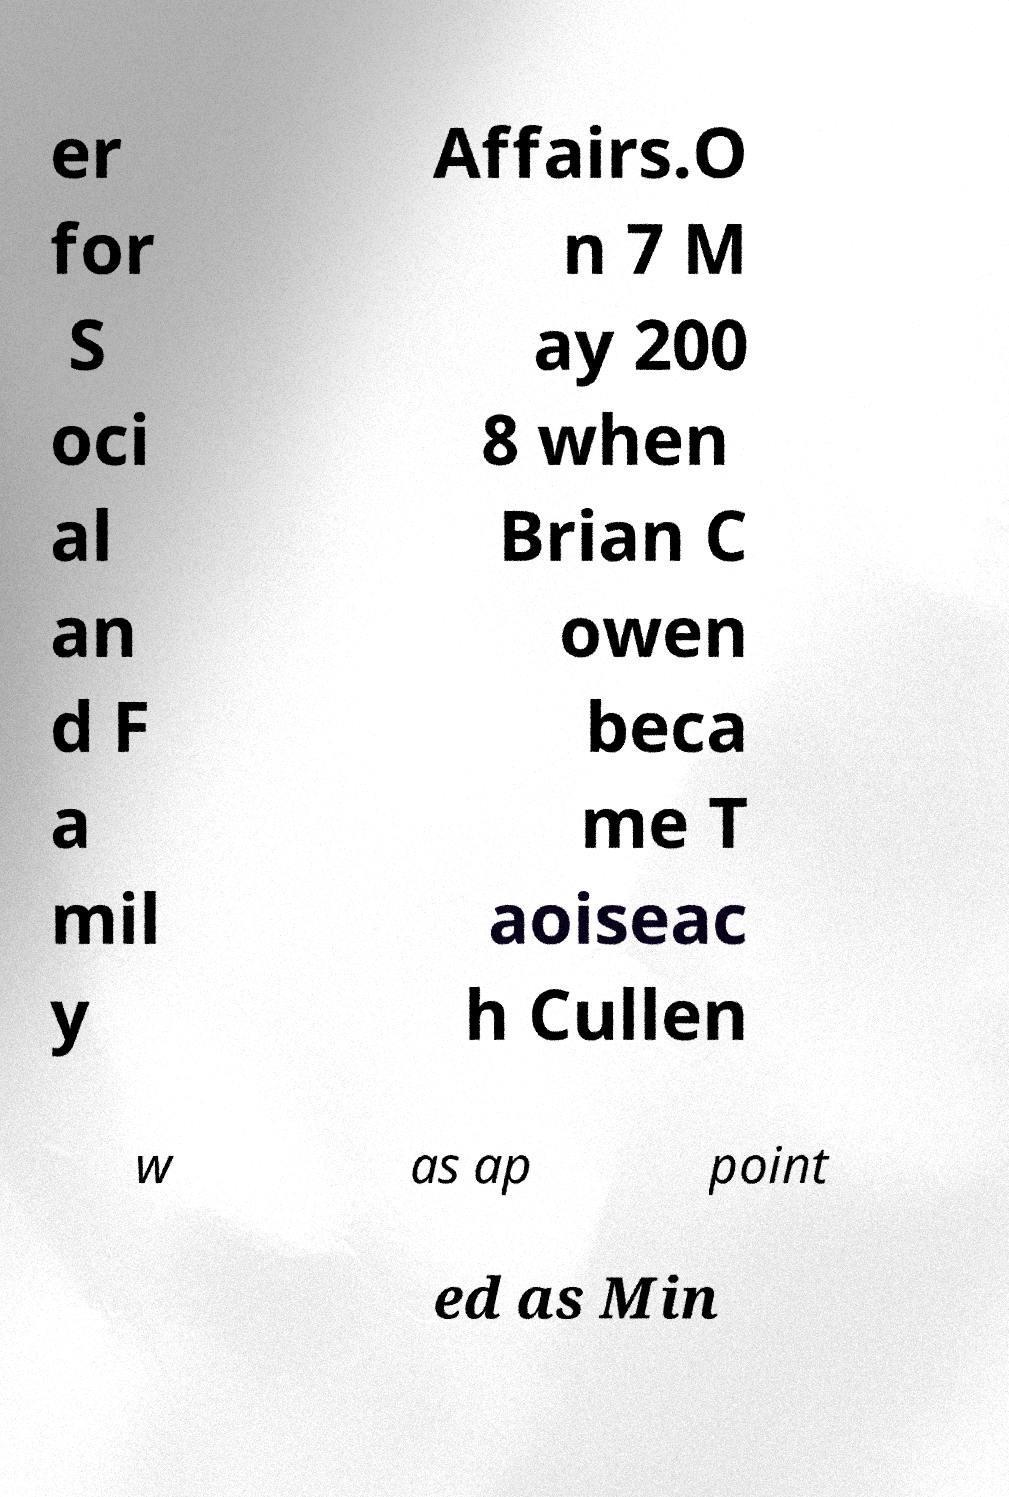For documentation purposes, I need the text within this image transcribed. Could you provide that? er for S oci al an d F a mil y Affairs.O n 7 M ay 200 8 when Brian C owen beca me T aoiseac h Cullen w as ap point ed as Min 